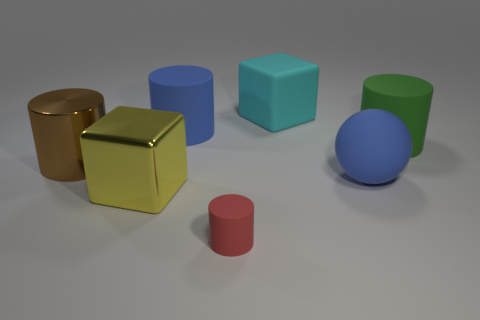How many other objects are there of the same color as the big sphere?
Keep it short and to the point. 1. How big is the rubber thing that is on the left side of the cylinder in front of the large yellow object?
Your response must be concise. Large. What material is the other large thing that is the same shape as the yellow object?
Your response must be concise. Rubber. How many other rubber cubes have the same size as the matte cube?
Make the answer very short. 0. Is the size of the red matte thing the same as the green rubber object?
Provide a short and direct response. No. What is the size of the object that is both to the left of the red cylinder and to the right of the big yellow block?
Ensure brevity in your answer.  Large. Are there more large matte blocks that are on the right side of the matte block than red things that are behind the big green rubber cylinder?
Give a very brief answer. No. There is a rubber object that is the same shape as the yellow shiny thing; what is its color?
Offer a terse response. Cyan. Is the color of the cube behind the big blue ball the same as the tiny matte cylinder?
Make the answer very short. No. What number of big green rubber cylinders are there?
Provide a succinct answer. 1. 